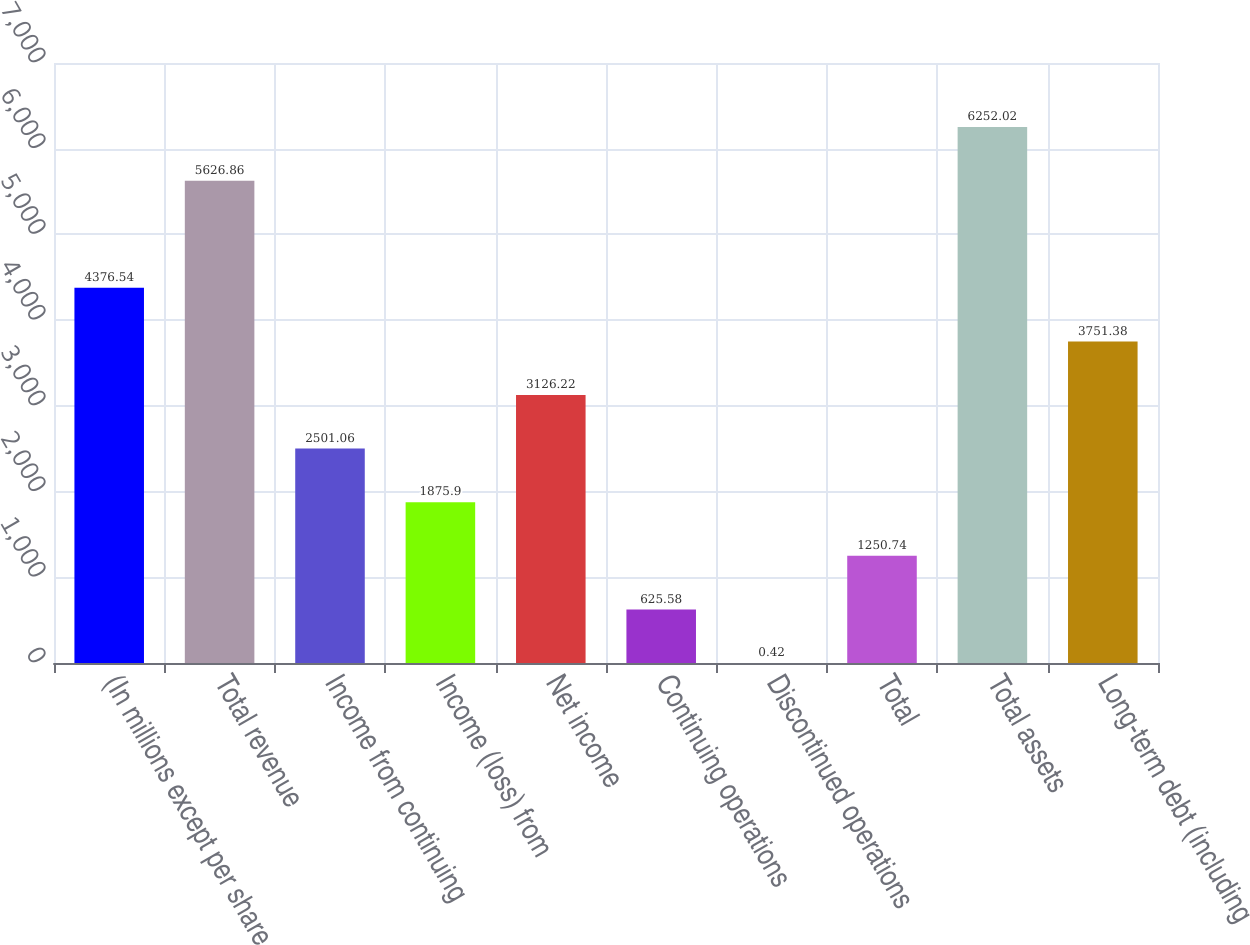Convert chart. <chart><loc_0><loc_0><loc_500><loc_500><bar_chart><fcel>(In millions except per share<fcel>Total revenue<fcel>Income from continuing<fcel>Income (loss) from<fcel>Net income<fcel>Continuing operations<fcel>Discontinued operations<fcel>Total<fcel>Total assets<fcel>Long-term debt (including<nl><fcel>4376.54<fcel>5626.86<fcel>2501.06<fcel>1875.9<fcel>3126.22<fcel>625.58<fcel>0.42<fcel>1250.74<fcel>6252.02<fcel>3751.38<nl></chart> 